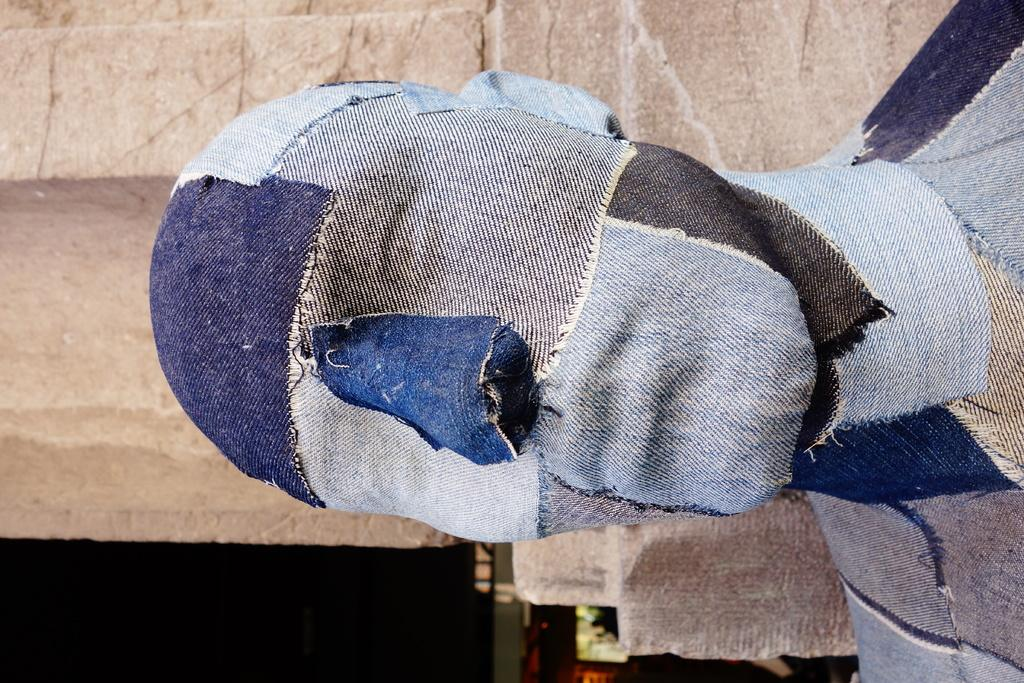In which direction is the image oriented? The image is oriented towards the left. What can be seen in the foreground of the image? There is a statue in the image. How is the statue decorated? The statue is covered with different colors of cloth. What type of structure can be seen in the background of the image? There is a stone wall in the background of the image. What is the mass of the statue in the image? The mass of the statue cannot be determined from the image alone, as it does not provide information about the statue's size or material. 